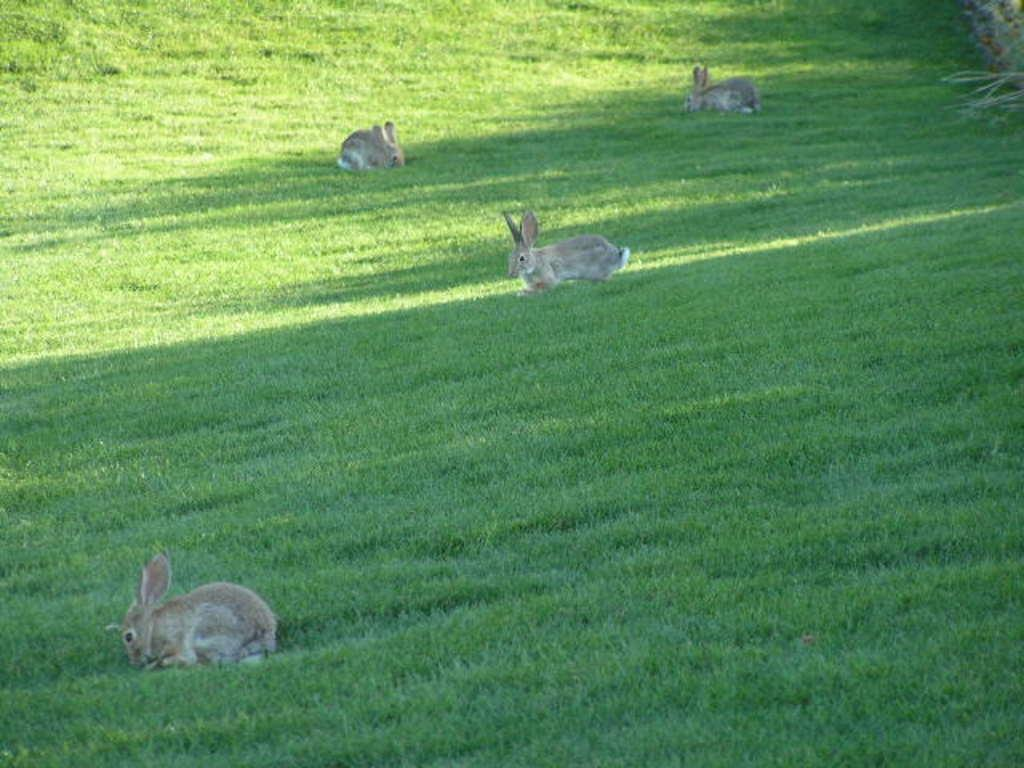How many rabbits are present in the image? There are four rabbits in the image. Where are the rabbits located? The rabbits are on the ground. What type of surface can be seen beneath the rabbits? There is grass on the ground. What can be seen on the right side of the image? There are plants on the right side of the image. What type of chess piece is the rabbit holding in the image? There is no chess piece present in the image, and the rabbits are not holding anything. Can you describe the heart rate of the rabbits in the image? The image does not provide information about the rabbits' heart rates, as it is a still photograph. 